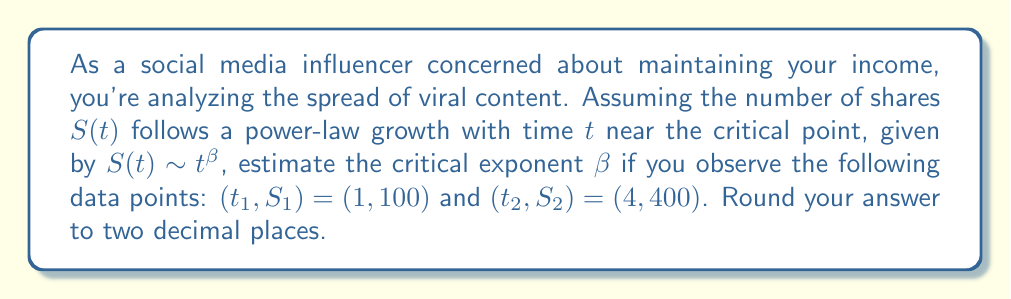Solve this math problem. To estimate the critical exponent $\beta$, we'll use the power-law relationship:

$S(t) \sim t^{\beta}$

1) We can write this as an equation:
   $S(t) = C t^{\beta}$, where $C$ is a constant.

2) Using the two data points, we can set up two equations:
   $100 = C \cdot 1^{\beta}$
   $400 = C \cdot 4^{\beta}$

3) Dividing the second equation by the first:
   $\frac{400}{100} = \frac{C \cdot 4^{\beta}}{C \cdot 1^{\beta}}$

4) Simplify:
   $4 = 4^{\beta}$

5) Take the logarithm of both sides:
   $\log 4 = \beta \log 4$

6) Solve for $\beta$:
   $\beta = \frac{\log 4}{\log 4} = 1$

7) Round to two decimal places:
   $\beta \approx 1.00$

This value indicates that the number of shares grows linearly with time near the critical point, which could be concerning for an influencer worried about maintaining rapid growth in their content's reach.
Answer: $\beta \approx 1.00$ 